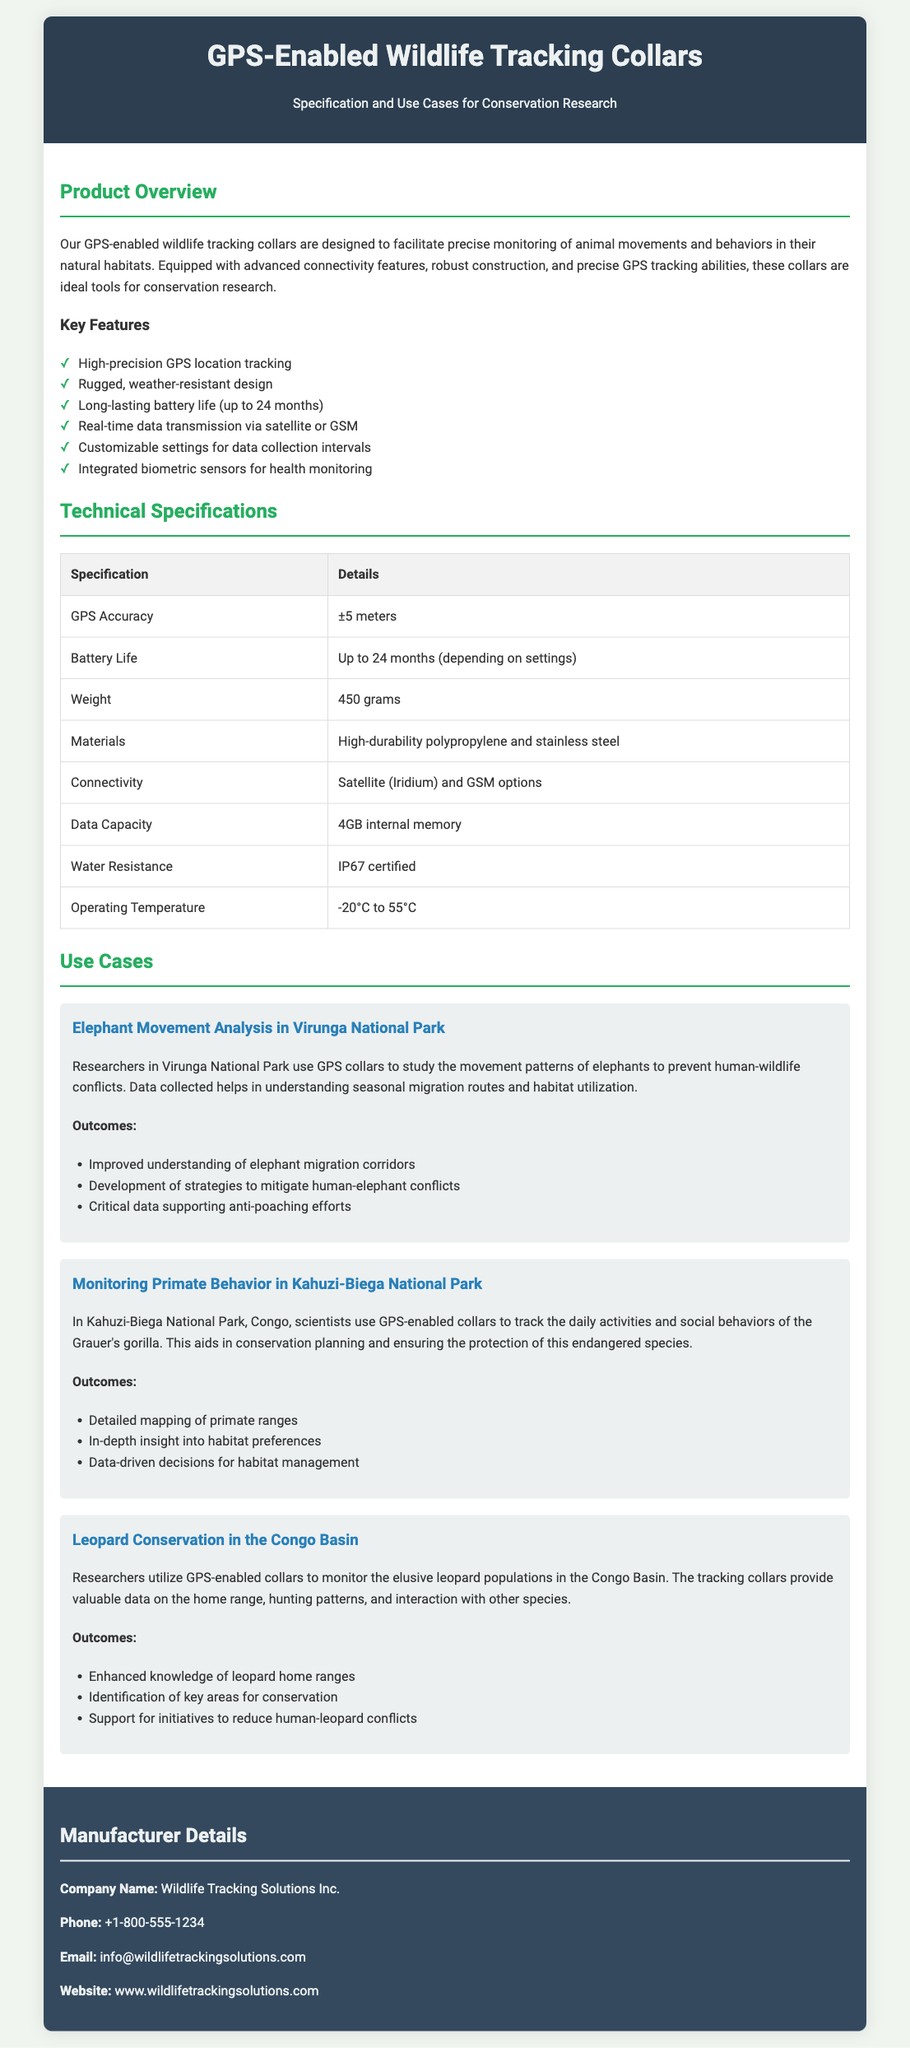What is the battery life? The battery life specified in the document indicates it can last up to 24 months, depending on settings.
Answer: Up to 24 months What is the weight of the collar? The document lists the weight of the collar as 450 grams.
Answer: 450 grams Which company manufactures the collars? The manufacturer information states the company name is Wildlife Tracking Solutions Inc.
Answer: Wildlife Tracking Solutions Inc What kind of connectivity options do the collars have? The connectivity options mentioned are Satellite (Iridium) and GSM options.
Answer: Satellite (Iridium) and GSM What is the main use case presented for monitoring gorillas? The document specifies monitoring primate behavior in Kahuzi-Biega National Park as the use case for gorilla tracking.
Answer: Monitoring primate behavior in Kahuzi-Biega National Park How does the collar help prevent human-elephant conflicts? The data collected from GPS collars helps in understanding seasonal migration routes and habitat utilization to prevent conflicts.
Answer: Understanding seasonal migration routes What is the water resistance rating of the collars? The specification indicates the collars are IP67 certified for water resistance.
Answer: IP67 certified What feature allows for health monitoring? Integrated biometric sensors are the features mentioned for health monitoring.
Answer: Integrated biometric sensors 